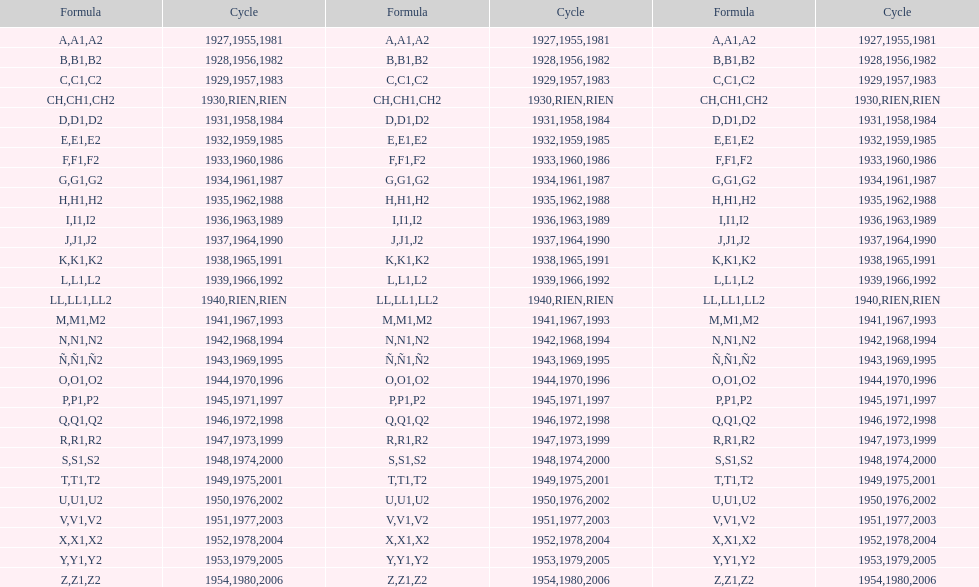What was the only year to use the code ch? 1930. 